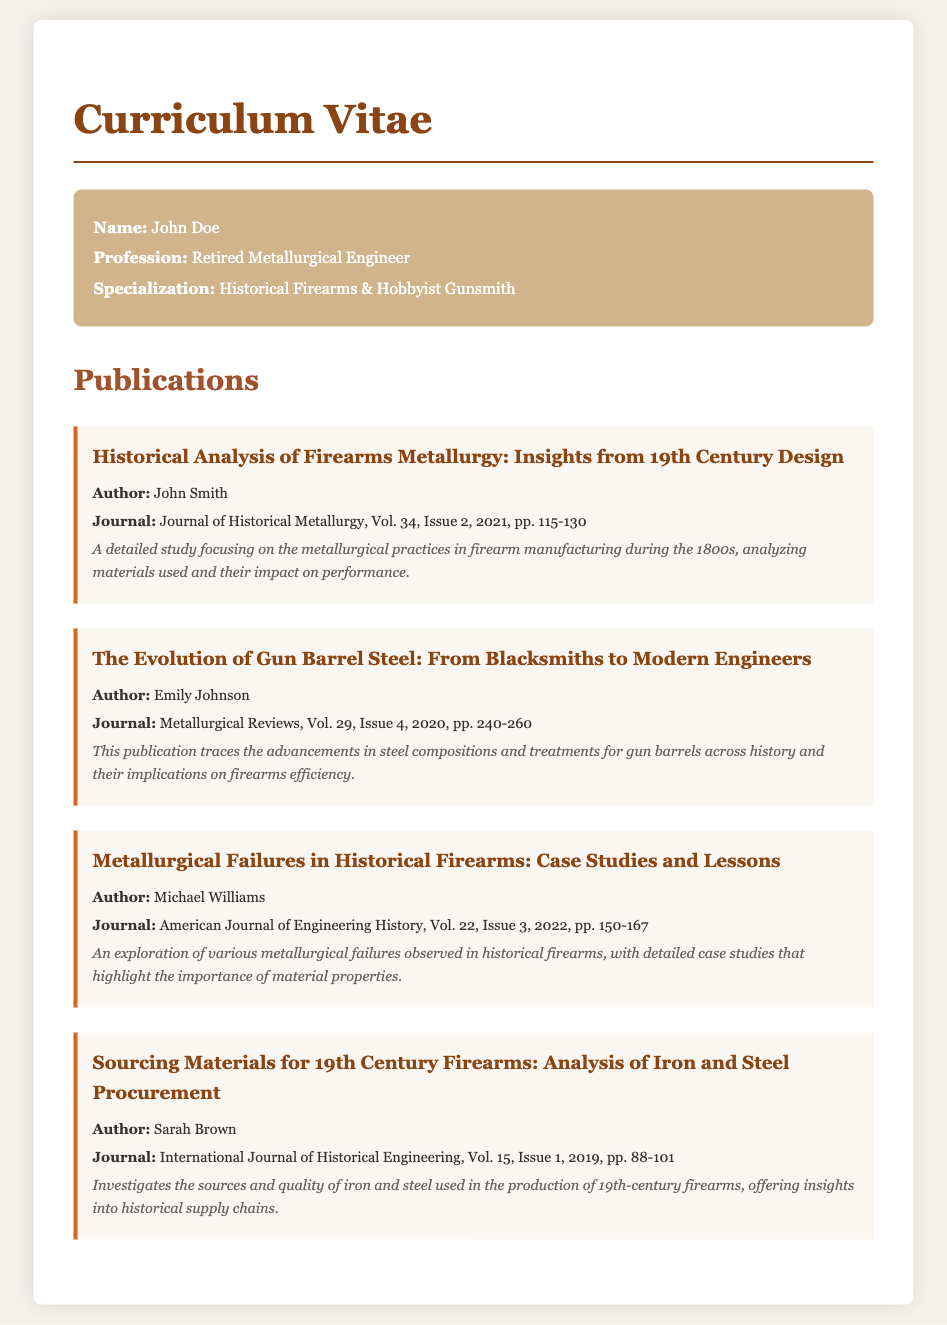What is the title of the first publication listed? The title of the first publication is presented under the publication section at the top of the list.
Answer: Historical Analysis of Firearms Metallurgy: Insights from 19th Century Design Who is the author of "The Evolution of Gun Barrel Steel"? The author of this publication is mentioned below the title in the publication details.
Answer: Emily Johnson What volume and issue number is associated with "Metallurgical Failures in Historical Firearms"? Volume and issue numbers are provided in the journal citation for each publication.
Answer: Vol. 22, Issue 3 In what year was "Sourcing Materials for 19th Century Firearms" published? The publication year is indicated in the citation for each listed article.
Answer: 2019 How many pages does the article "Metallurgical Failures in Historical Firearms" cover? The page range is included in the journal citation for each publication as part of the details.
Answer: pp. 150-167 Which journal published the article by John Smith? Each publication specifies the journal in which it was published directly after the author's name.
Answer: Journal of Historical Metallurgy What common theme is explored across all publications listed? The overarching theme involves the metallurgical aspects and historical context related to firearms, as inferred from the titles and descriptions.
Answer: Metallurgy and Firearms What is the primary focus of the publication by Sarah Brown? The focus is indicated in the description provided for each publication, summarizing its main topic.
Answer: Iron and Steel Procurement 